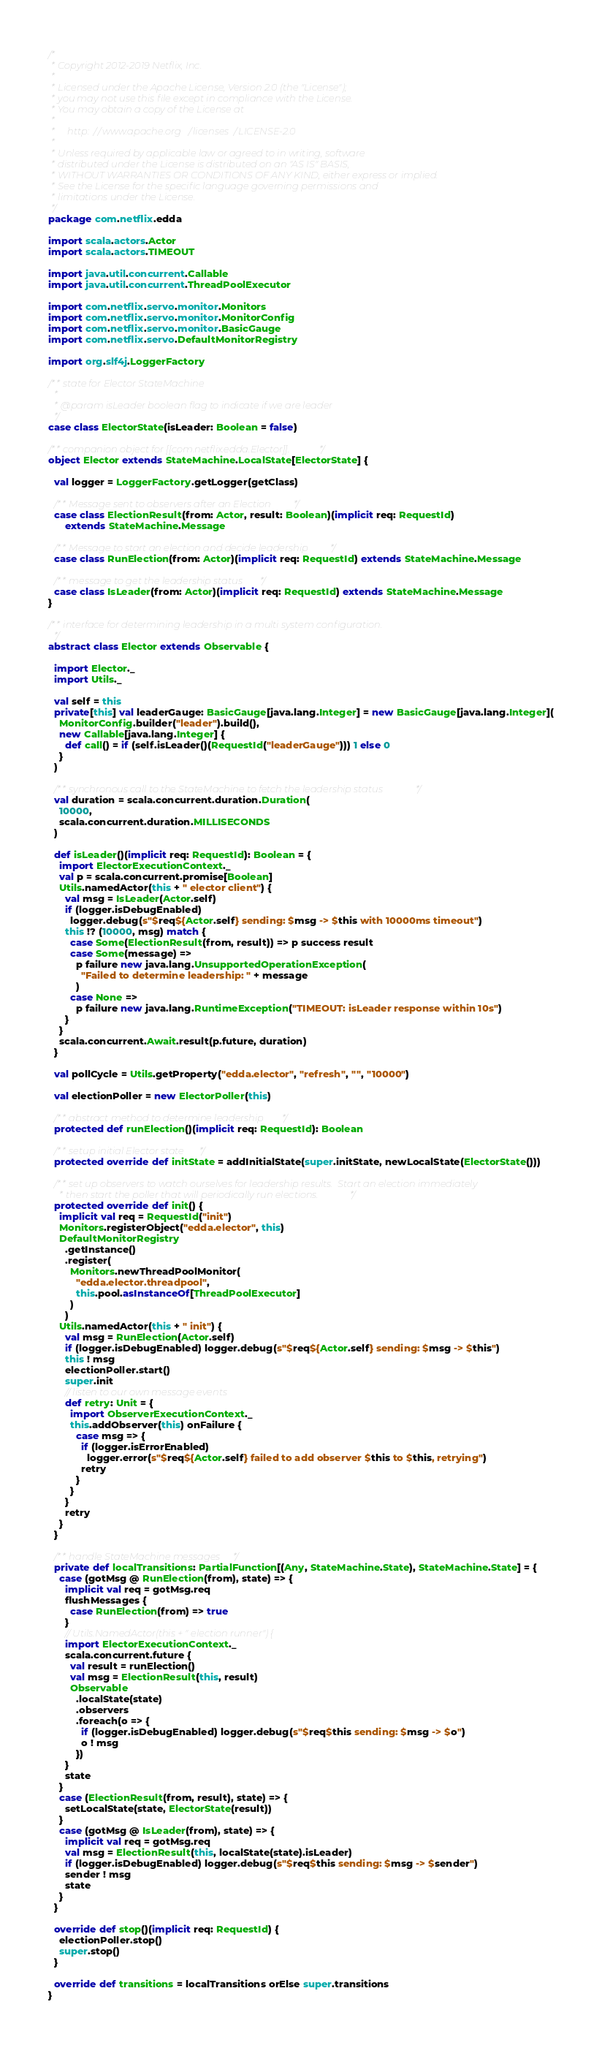<code> <loc_0><loc_0><loc_500><loc_500><_Scala_>/*
 * Copyright 2012-2019 Netflix, Inc.
 *
 * Licensed under the Apache License, Version 2.0 (the "License");
 * you may not use this file except in compliance with the License.
 * You may obtain a copy of the License at
 *
 *     http://www.apache.org/licenses/LICENSE-2.0
 *
 * Unless required by applicable law or agreed to in writing, software
 * distributed under the License is distributed on an "AS IS" BASIS,
 * WITHOUT WARRANTIES OR CONDITIONS OF ANY KIND, either express or implied.
 * See the License for the specific language governing permissions and
 * limitations under the License.
 */
package com.netflix.edda

import scala.actors.Actor
import scala.actors.TIMEOUT

import java.util.concurrent.Callable
import java.util.concurrent.ThreadPoolExecutor

import com.netflix.servo.monitor.Monitors
import com.netflix.servo.monitor.MonitorConfig
import com.netflix.servo.monitor.BasicGauge
import com.netflix.servo.DefaultMonitorRegistry

import org.slf4j.LoggerFactory

/** state for Elector StateMachine
  *
  * @param isLeader boolean flag to indicate if we are leader
  */
case class ElectorState(isLeader: Boolean = false)

/** companion object for [[com.netflix.edda.Elector]]. */
object Elector extends StateMachine.LocalState[ElectorState] {

  val logger = LoggerFactory.getLogger(getClass)

  /** Message sent to observers after an Election */
  case class ElectionResult(from: Actor, result: Boolean)(implicit req: RequestId)
      extends StateMachine.Message

  /** Message to start an election and decide leadership */
  case class RunElection(from: Actor)(implicit req: RequestId) extends StateMachine.Message

  /** message to get the leadership status */
  case class IsLeader(from: Actor)(implicit req: RequestId) extends StateMachine.Message
}

/** interface for determining leadership in a multi system configuration.
  */
abstract class Elector extends Observable {

  import Elector._
  import Utils._

  val self = this
  private[this] val leaderGauge: BasicGauge[java.lang.Integer] = new BasicGauge[java.lang.Integer](
    MonitorConfig.builder("leader").build(),
    new Callable[java.lang.Integer] {
      def call() = if (self.isLeader()(RequestId("leaderGauge"))) 1 else 0
    }
  )

  /** synchronous call to the StateMachine to fetch the leadership status */
  val duration = scala.concurrent.duration.Duration(
    10000,
    scala.concurrent.duration.MILLISECONDS
  )

  def isLeader()(implicit req: RequestId): Boolean = {
    import ElectorExecutionContext._
    val p = scala.concurrent.promise[Boolean]
    Utils.namedActor(this + " elector client") {
      val msg = IsLeader(Actor.self)
      if (logger.isDebugEnabled)
        logger.debug(s"$req${Actor.self} sending: $msg -> $this with 10000ms timeout")
      this !? (10000, msg) match {
        case Some(ElectionResult(from, result)) => p success result
        case Some(message) =>
          p failure new java.lang.UnsupportedOperationException(
            "Failed to determine leadership: " + message
          )
        case None =>
          p failure new java.lang.RuntimeException("TIMEOUT: isLeader response within 10s")
      }
    }
    scala.concurrent.Await.result(p.future, duration)
  }

  val pollCycle = Utils.getProperty("edda.elector", "refresh", "", "10000")

  val electionPoller = new ElectorPoller(this)

  /** abstract method to determine leadership */
  protected def runElection()(implicit req: RequestId): Boolean

  /** setup initial Elector state */
  protected override def initState = addInitialState(super.initState, newLocalState(ElectorState()))

  /** set up observers to watch ourselves for leadership results.  Start an election immediately
    * then start the poller that will periodically run elections. */
  protected override def init() {
    implicit val req = RequestId("init")
    Monitors.registerObject("edda.elector", this)
    DefaultMonitorRegistry
      .getInstance()
      .register(
        Monitors.newThreadPoolMonitor(
          "edda.elector.threadpool",
          this.pool.asInstanceOf[ThreadPoolExecutor]
        )
      )
    Utils.namedActor(this + " init") {
      val msg = RunElection(Actor.self)
      if (logger.isDebugEnabled) logger.debug(s"$req${Actor.self} sending: $msg -> $this")
      this ! msg
      electionPoller.start()
      super.init
      // listen to our own message events
      def retry: Unit = {
        import ObserverExecutionContext._
        this.addObserver(this) onFailure {
          case msg => {
            if (logger.isErrorEnabled)
              logger.error(s"$req${Actor.self} failed to add observer $this to $this, retrying")
            retry
          }
        }
      }
      retry
    }
  }

  /** handle StateMachine messages */
  private def localTransitions: PartialFunction[(Any, StateMachine.State), StateMachine.State] = {
    case (gotMsg @ RunElection(from), state) => {
      implicit val req = gotMsg.req
      flushMessages {
        case RunElection(from) => true
      }
      // Utils.NamedActor(this + " election runner") {
      import ElectorExecutionContext._
      scala.concurrent.future {
        val result = runElection()
        val msg = ElectionResult(this, result)
        Observable
          .localState(state)
          .observers
          .foreach(o => {
            if (logger.isDebugEnabled) logger.debug(s"$req$this sending: $msg -> $o")
            o ! msg
          })
      }
      state
    }
    case (ElectionResult(from, result), state) => {
      setLocalState(state, ElectorState(result))
    }
    case (gotMsg @ IsLeader(from), state) => {
      implicit val req = gotMsg.req
      val msg = ElectionResult(this, localState(state).isLeader)
      if (logger.isDebugEnabled) logger.debug(s"$req$this sending: $msg -> $sender")
      sender ! msg
      state
    }
  }

  override def stop()(implicit req: RequestId) {
    electionPoller.stop()
    super.stop()
  }

  override def transitions = localTransitions orElse super.transitions
}
</code> 